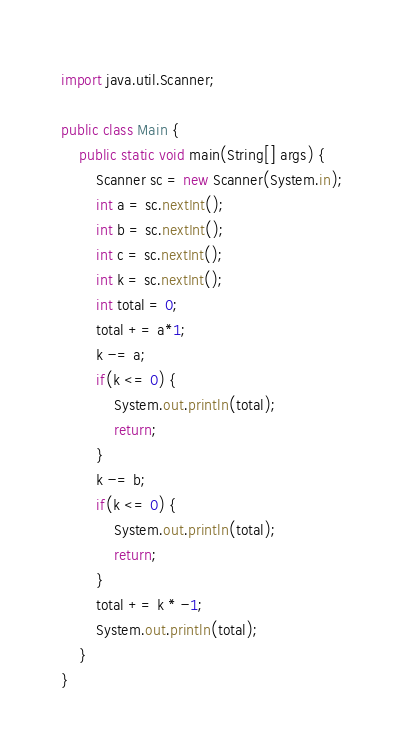<code> <loc_0><loc_0><loc_500><loc_500><_Java_>import java.util.Scanner;

public class Main {
    public static void main(String[] args) {
        Scanner sc = new Scanner(System.in);
        int a = sc.nextInt();
        int b = sc.nextInt();
        int c = sc.nextInt();
        int k = sc.nextInt();
        int total = 0;
        total += a*1;
        k -= a;
        if(k <= 0) {
            System.out.println(total);
            return;
        }
        k -= b;
        if(k <= 0) {
            System.out.println(total);
            return;
        }
        total += k * -1;
        System.out.println(total);
    }
}</code> 